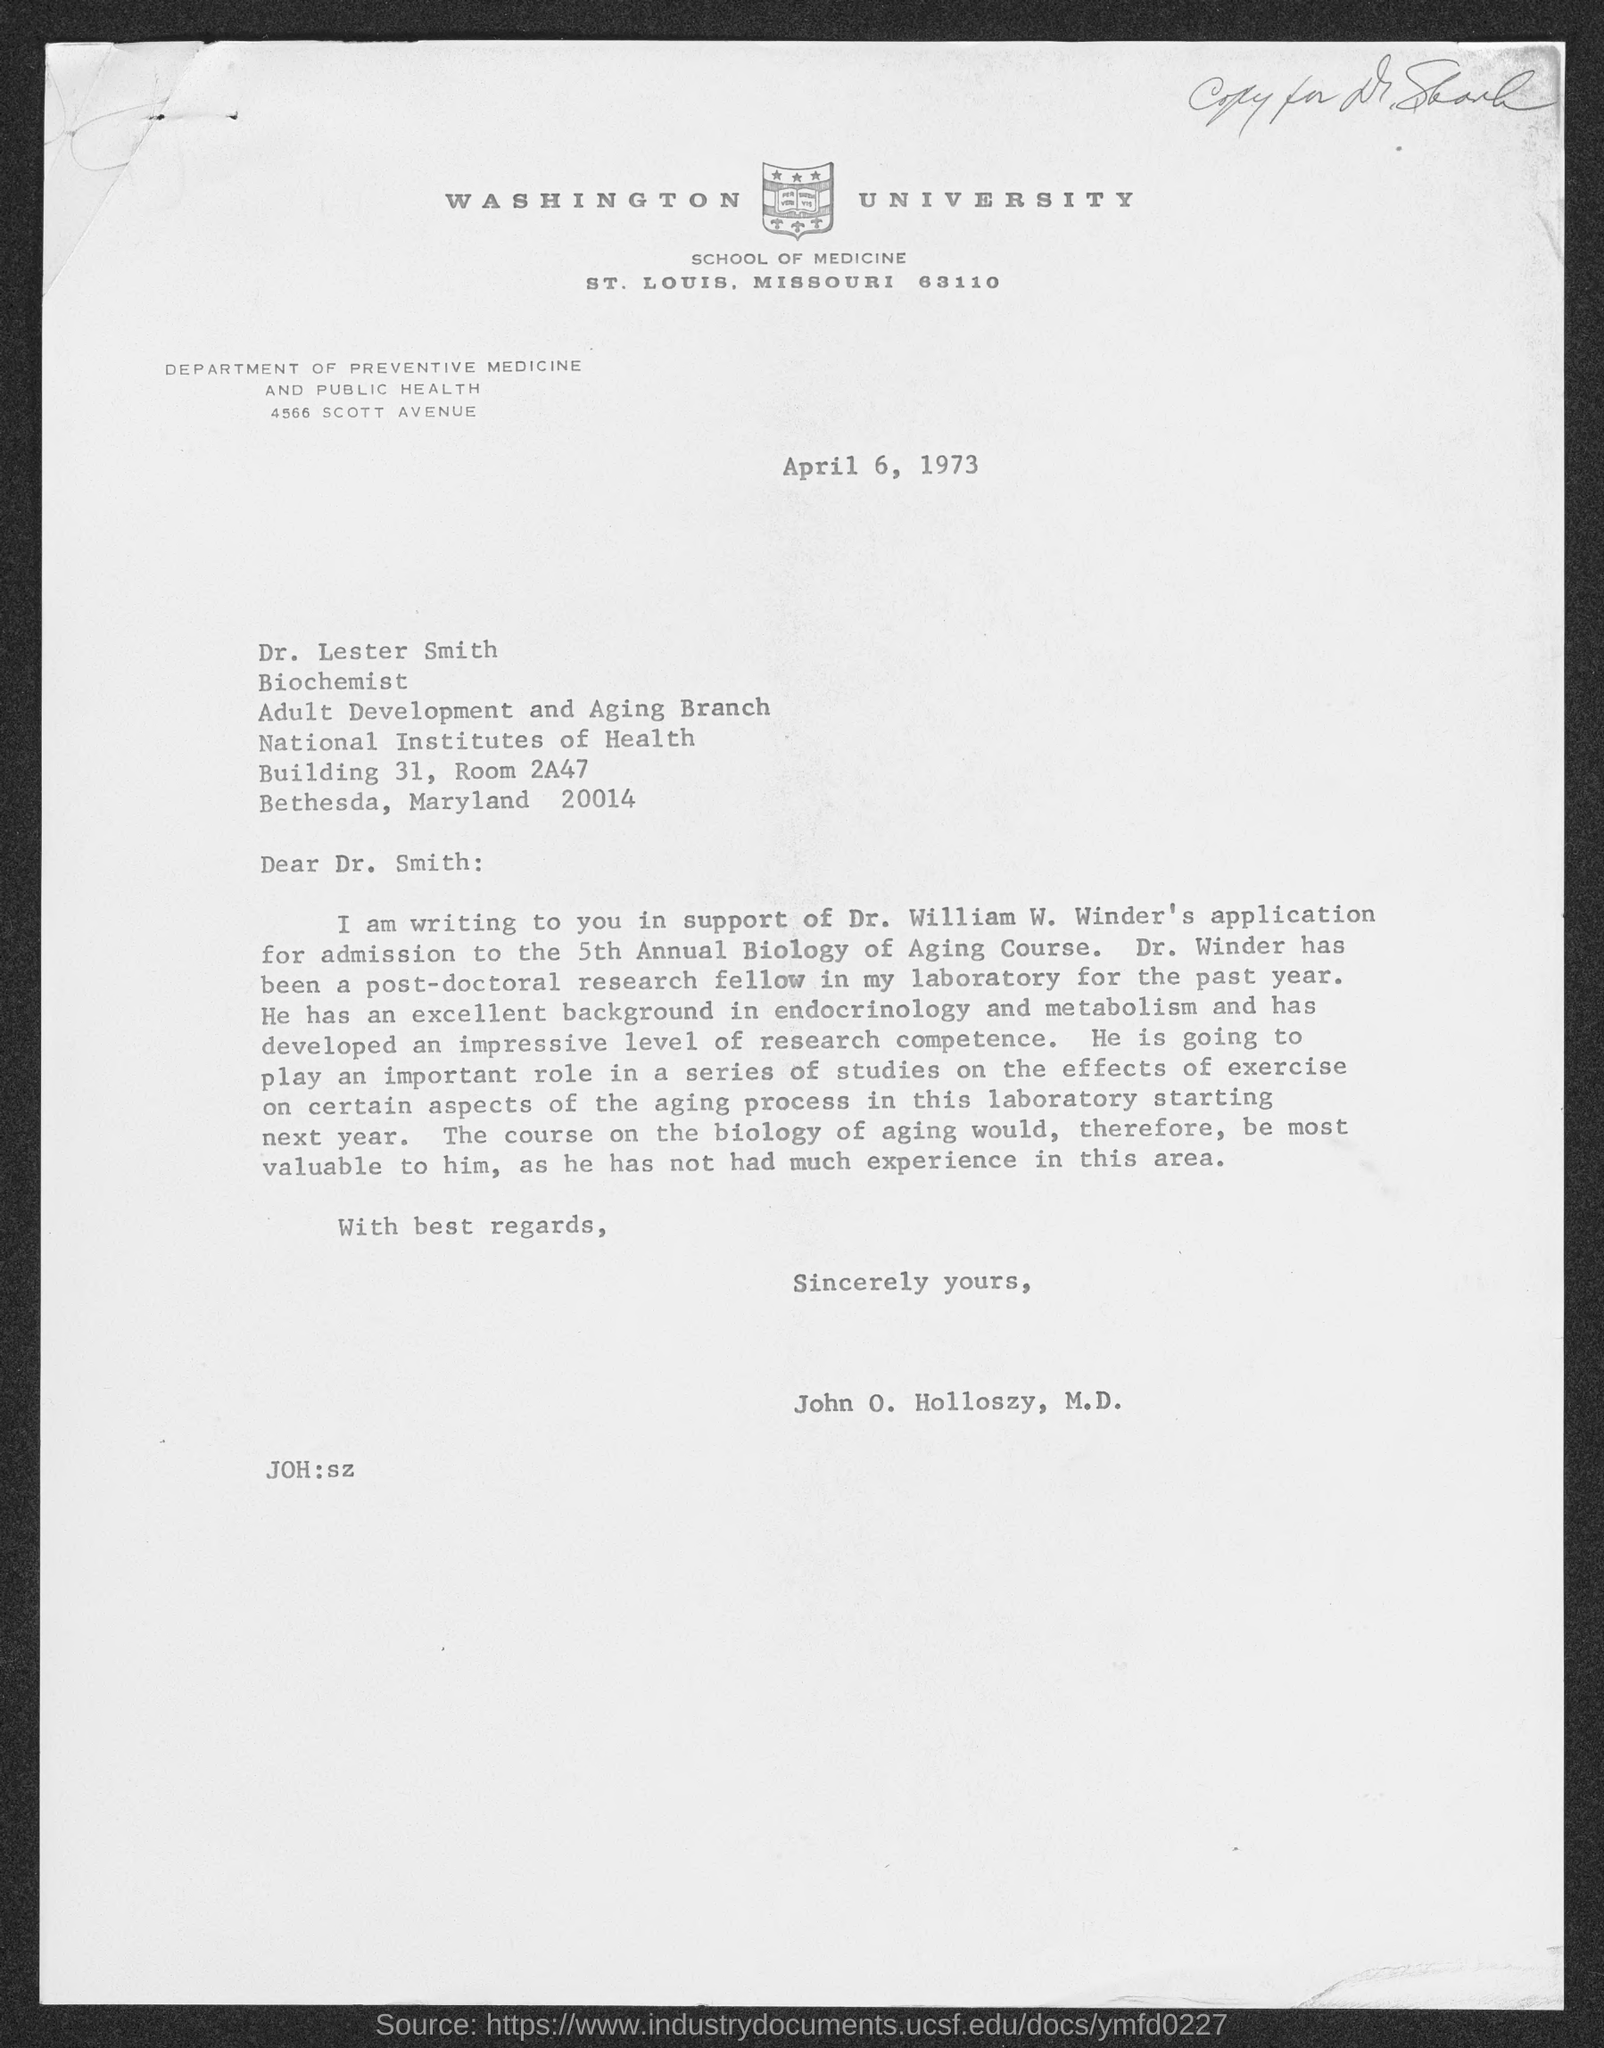What is the date?
Offer a terse response. April 6, 1973. What is the salutation of this letter?
Keep it short and to the point. Dear Dr. Smith:. 